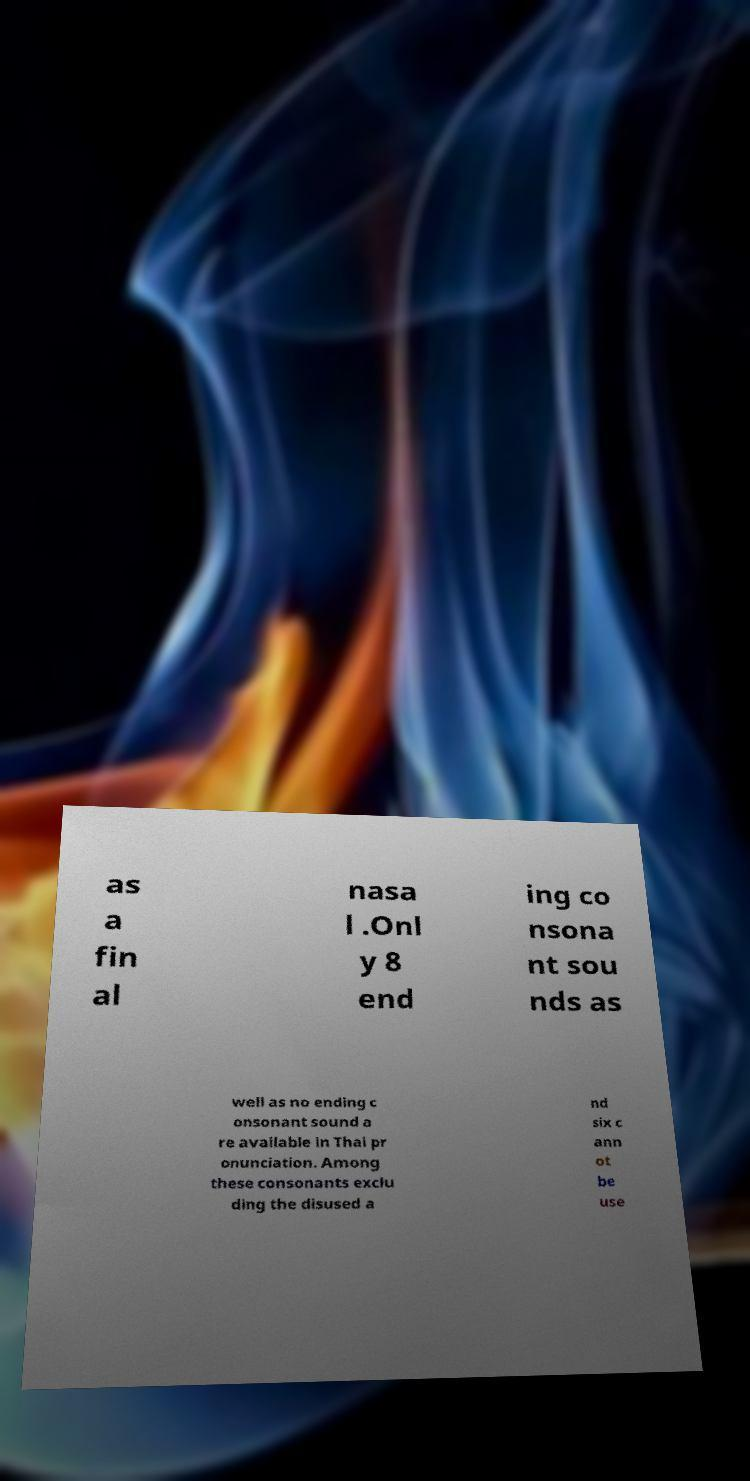Could you extract and type out the text from this image? as a fin al nasa l .Onl y 8 end ing co nsona nt sou nds as well as no ending c onsonant sound a re available in Thai pr onunciation. Among these consonants exclu ding the disused a nd six c ann ot be use 